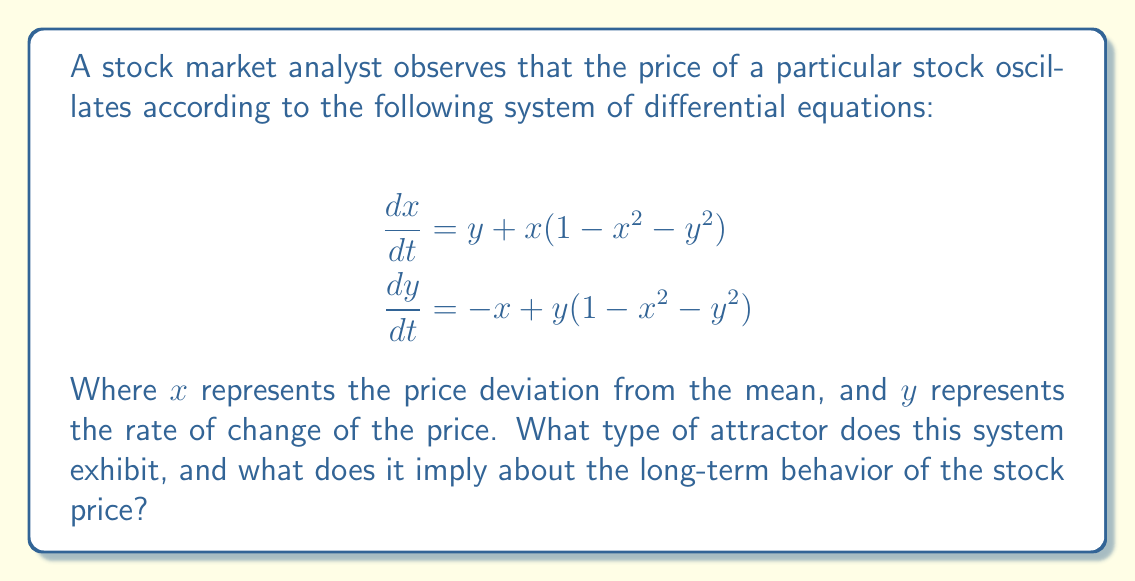Show me your answer to this math problem. To determine the type of attractor and the long-term behavior of the stock price, we need to analyze the given system of differential equations:

1. Recognize the system:
   This system is known as the Van der Pol oscillator in polar form.

2. Analyze the structure:
   - The equations can be written in polar coordinates as:
     $$\frac{dr}{dt} = r(1-r^2)$$
     $$\frac{d\theta}{dt} = -1$$
   Where $r = \sqrt{x^2 + y^2}$ and $\theta = \arctan(y/x)$.

3. Identify the limit cycle:
   - The radial equation $\frac{dr}{dt} = r(1-r^2)$ has three equilibrium points:
     $r = 0$ (unstable) and $r = \pm 1$ (stable).
   - This indicates the existence of a stable limit cycle at $r = 1$.

4. Analyze the angular component:
   - $\frac{d\theta}{dt} = -1$ implies a constant angular velocity in the clockwise direction.

5. Conclude the attractor type:
   - The system exhibits a stable limit cycle attractor with radius 1.

6. Interpret for stock price behavior:
   - The stock price will tend to oscillate in a regular pattern around its mean value.
   - The amplitude of the oscillation will approach a fixed value (corresponding to $r = 1$).
   - The oscillation will occur at a constant frequency (determined by $\frac{d\theta}{dt} = -1$).

This analysis provides a robust framework for predicting long-term market behavior, which is valuable for risk assessment and creating training materials.
Answer: Stable limit cycle attractor; periodic oscillations with fixed amplitude around mean price. 